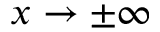<formula> <loc_0><loc_0><loc_500><loc_500>x \to \pm \infty</formula> 